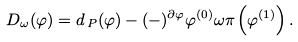Convert formula to latex. <formula><loc_0><loc_0><loc_500><loc_500>D _ { \omega } ( \varphi ) = d _ { \, P } ( \varphi ) - ( - ) ^ { \partial \varphi } \varphi ^ { ( 0 ) } \omega \pi \left ( \varphi ^ { ( 1 ) } \right ) .</formula> 